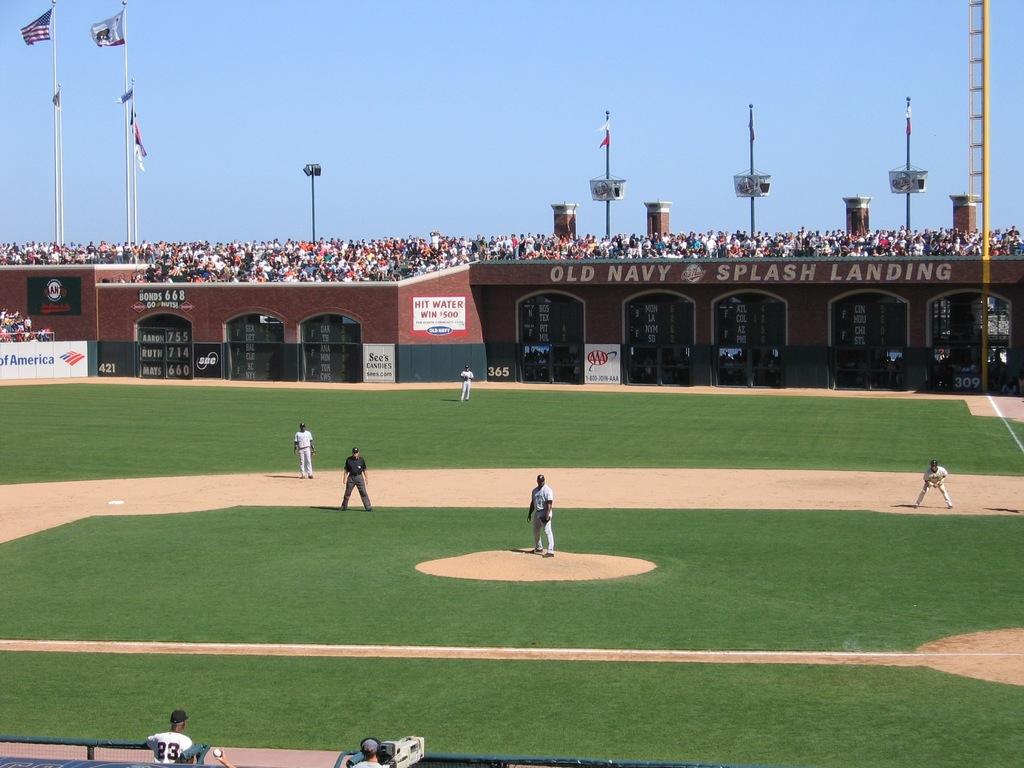What is the word after splash?
Your response must be concise. Landing. 